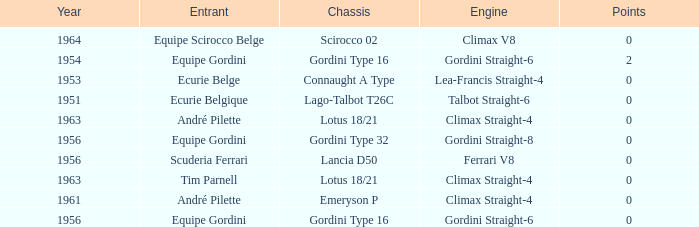Who was in 1963? Tim Parnell, André Pilette. 